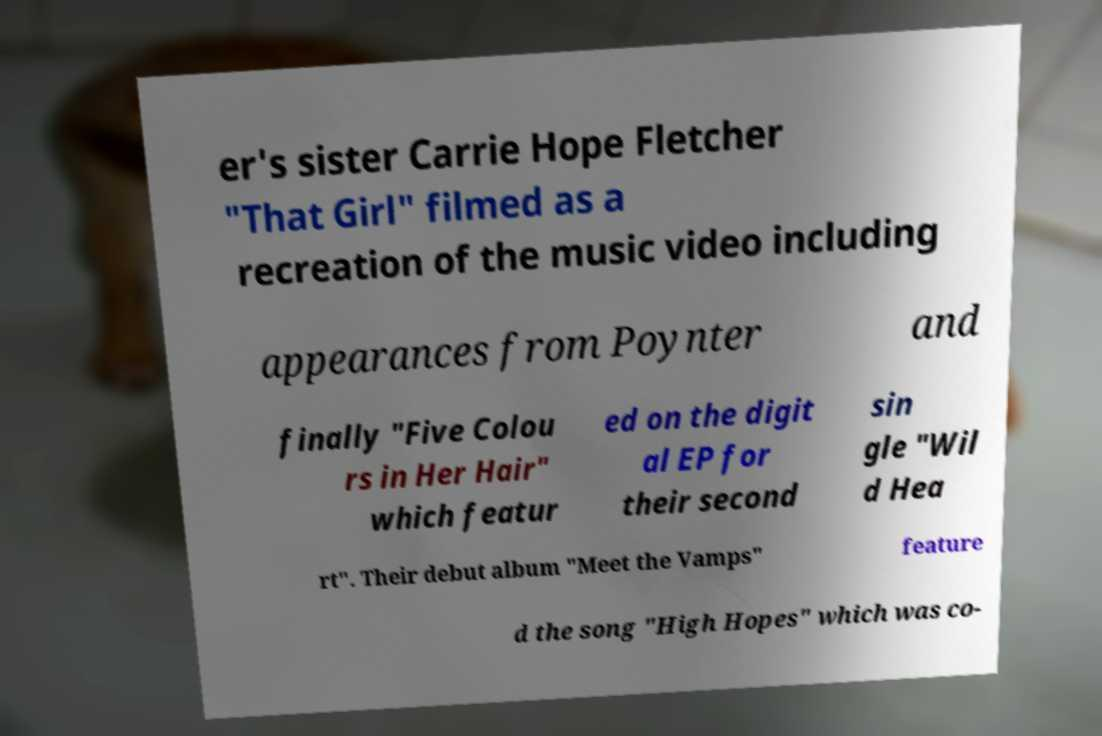Can you accurately transcribe the text from the provided image for me? er's sister Carrie Hope Fletcher "That Girl" filmed as a recreation of the music video including appearances from Poynter and finally "Five Colou rs in Her Hair" which featur ed on the digit al EP for their second sin gle "Wil d Hea rt". Their debut album "Meet the Vamps" feature d the song "High Hopes" which was co- 